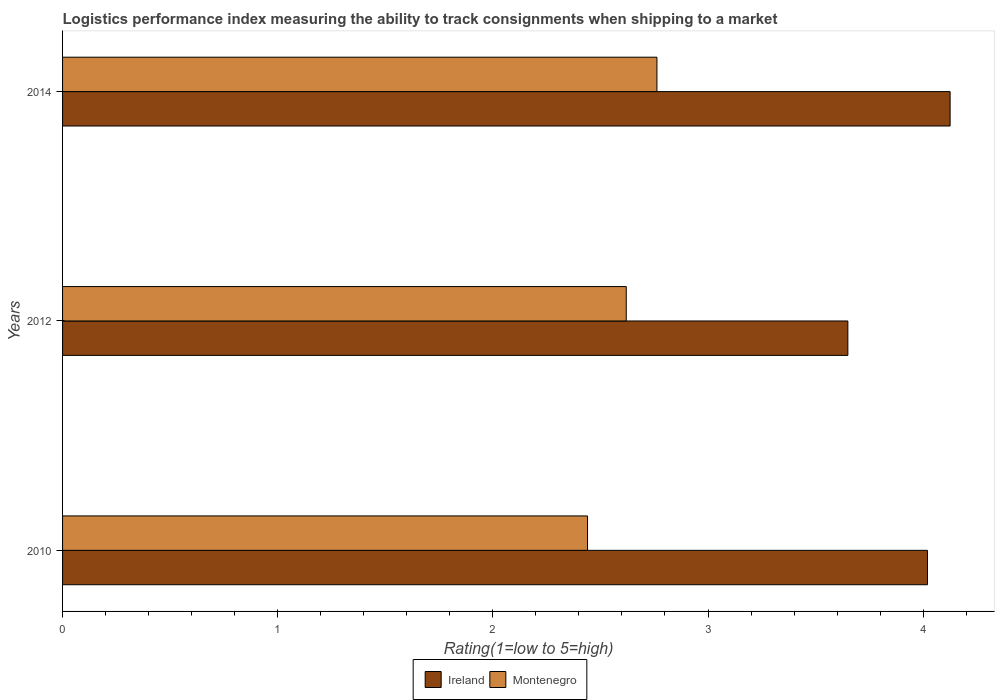Are the number of bars per tick equal to the number of legend labels?
Provide a succinct answer. Yes. How many bars are there on the 2nd tick from the bottom?
Provide a short and direct response. 2. What is the Logistic performance index in Ireland in 2010?
Offer a terse response. 4.02. Across all years, what is the maximum Logistic performance index in Ireland?
Your response must be concise. 4.13. Across all years, what is the minimum Logistic performance index in Ireland?
Provide a succinct answer. 3.65. In which year was the Logistic performance index in Montenegro maximum?
Give a very brief answer. 2014. What is the total Logistic performance index in Ireland in the graph?
Provide a short and direct response. 11.8. What is the difference between the Logistic performance index in Ireland in 2010 and that in 2012?
Provide a short and direct response. 0.37. What is the difference between the Logistic performance index in Montenegro in 2010 and the Logistic performance index in Ireland in 2012?
Your response must be concise. -1.21. What is the average Logistic performance index in Montenegro per year?
Give a very brief answer. 2.61. In the year 2010, what is the difference between the Logistic performance index in Montenegro and Logistic performance index in Ireland?
Keep it short and to the point. -1.58. In how many years, is the Logistic performance index in Ireland greater than 3 ?
Ensure brevity in your answer.  3. What is the ratio of the Logistic performance index in Ireland in 2012 to that in 2014?
Your response must be concise. 0.88. Is the difference between the Logistic performance index in Montenegro in 2010 and 2012 greater than the difference between the Logistic performance index in Ireland in 2010 and 2012?
Offer a terse response. No. What is the difference between the highest and the second highest Logistic performance index in Ireland?
Offer a very short reply. 0.11. What is the difference between the highest and the lowest Logistic performance index in Montenegro?
Keep it short and to the point. 0.32. In how many years, is the Logistic performance index in Montenegro greater than the average Logistic performance index in Montenegro taken over all years?
Your answer should be very brief. 2. Is the sum of the Logistic performance index in Montenegro in 2010 and 2014 greater than the maximum Logistic performance index in Ireland across all years?
Provide a succinct answer. Yes. What does the 1st bar from the top in 2014 represents?
Keep it short and to the point. Montenegro. What does the 1st bar from the bottom in 2010 represents?
Give a very brief answer. Ireland. How many bars are there?
Your answer should be compact. 6. Are the values on the major ticks of X-axis written in scientific E-notation?
Make the answer very short. No. Does the graph contain any zero values?
Ensure brevity in your answer.  No. How many legend labels are there?
Your answer should be very brief. 2. What is the title of the graph?
Offer a terse response. Logistics performance index measuring the ability to track consignments when shipping to a market. Does "Lithuania" appear as one of the legend labels in the graph?
Provide a succinct answer. No. What is the label or title of the X-axis?
Ensure brevity in your answer.  Rating(1=low to 5=high). What is the label or title of the Y-axis?
Make the answer very short. Years. What is the Rating(1=low to 5=high) of Ireland in 2010?
Offer a very short reply. 4.02. What is the Rating(1=low to 5=high) in Montenegro in 2010?
Give a very brief answer. 2.44. What is the Rating(1=low to 5=high) of Ireland in 2012?
Offer a terse response. 3.65. What is the Rating(1=low to 5=high) in Montenegro in 2012?
Ensure brevity in your answer.  2.62. What is the Rating(1=low to 5=high) in Ireland in 2014?
Your response must be concise. 4.13. What is the Rating(1=low to 5=high) of Montenegro in 2014?
Keep it short and to the point. 2.76. Across all years, what is the maximum Rating(1=low to 5=high) of Ireland?
Keep it short and to the point. 4.13. Across all years, what is the maximum Rating(1=low to 5=high) of Montenegro?
Provide a short and direct response. 2.76. Across all years, what is the minimum Rating(1=low to 5=high) of Ireland?
Your response must be concise. 3.65. Across all years, what is the minimum Rating(1=low to 5=high) in Montenegro?
Make the answer very short. 2.44. What is the total Rating(1=low to 5=high) of Ireland in the graph?
Ensure brevity in your answer.  11.8. What is the total Rating(1=low to 5=high) of Montenegro in the graph?
Ensure brevity in your answer.  7.82. What is the difference between the Rating(1=low to 5=high) of Ireland in 2010 and that in 2012?
Provide a succinct answer. 0.37. What is the difference between the Rating(1=low to 5=high) in Montenegro in 2010 and that in 2012?
Your response must be concise. -0.18. What is the difference between the Rating(1=low to 5=high) in Ireland in 2010 and that in 2014?
Provide a short and direct response. -0.11. What is the difference between the Rating(1=low to 5=high) in Montenegro in 2010 and that in 2014?
Make the answer very short. -0.32. What is the difference between the Rating(1=low to 5=high) in Ireland in 2012 and that in 2014?
Provide a succinct answer. -0.48. What is the difference between the Rating(1=low to 5=high) in Montenegro in 2012 and that in 2014?
Ensure brevity in your answer.  -0.14. What is the difference between the Rating(1=low to 5=high) of Ireland in 2010 and the Rating(1=low to 5=high) of Montenegro in 2012?
Offer a very short reply. 1.4. What is the difference between the Rating(1=low to 5=high) of Ireland in 2010 and the Rating(1=low to 5=high) of Montenegro in 2014?
Offer a terse response. 1.26. What is the difference between the Rating(1=low to 5=high) of Ireland in 2012 and the Rating(1=low to 5=high) of Montenegro in 2014?
Your answer should be compact. 0.89. What is the average Rating(1=low to 5=high) of Ireland per year?
Your answer should be very brief. 3.93. What is the average Rating(1=low to 5=high) in Montenegro per year?
Your answer should be compact. 2.61. In the year 2010, what is the difference between the Rating(1=low to 5=high) in Ireland and Rating(1=low to 5=high) in Montenegro?
Your response must be concise. 1.58. In the year 2014, what is the difference between the Rating(1=low to 5=high) in Ireland and Rating(1=low to 5=high) in Montenegro?
Offer a terse response. 1.36. What is the ratio of the Rating(1=low to 5=high) of Ireland in 2010 to that in 2012?
Give a very brief answer. 1.1. What is the ratio of the Rating(1=low to 5=high) in Montenegro in 2010 to that in 2012?
Make the answer very short. 0.93. What is the ratio of the Rating(1=low to 5=high) of Ireland in 2010 to that in 2014?
Your answer should be very brief. 0.97. What is the ratio of the Rating(1=low to 5=high) of Montenegro in 2010 to that in 2014?
Offer a terse response. 0.88. What is the ratio of the Rating(1=low to 5=high) of Ireland in 2012 to that in 2014?
Your response must be concise. 0.88. What is the ratio of the Rating(1=low to 5=high) of Montenegro in 2012 to that in 2014?
Keep it short and to the point. 0.95. What is the difference between the highest and the second highest Rating(1=low to 5=high) in Ireland?
Provide a succinct answer. 0.11. What is the difference between the highest and the second highest Rating(1=low to 5=high) in Montenegro?
Your response must be concise. 0.14. What is the difference between the highest and the lowest Rating(1=low to 5=high) in Ireland?
Ensure brevity in your answer.  0.48. What is the difference between the highest and the lowest Rating(1=low to 5=high) of Montenegro?
Provide a succinct answer. 0.32. 